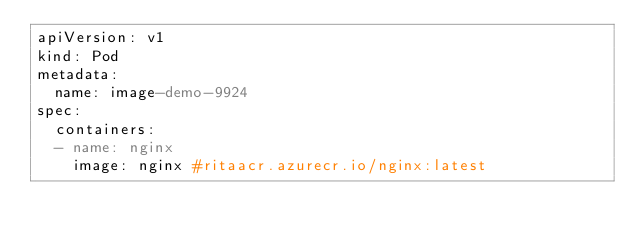<code> <loc_0><loc_0><loc_500><loc_500><_YAML_>apiVersion: v1
kind: Pod
metadata:
  name: image-demo-9924
spec:
  containers:
  - name: nginx
    image: nginx #ritaacr.azurecr.io/nginx:latest</code> 